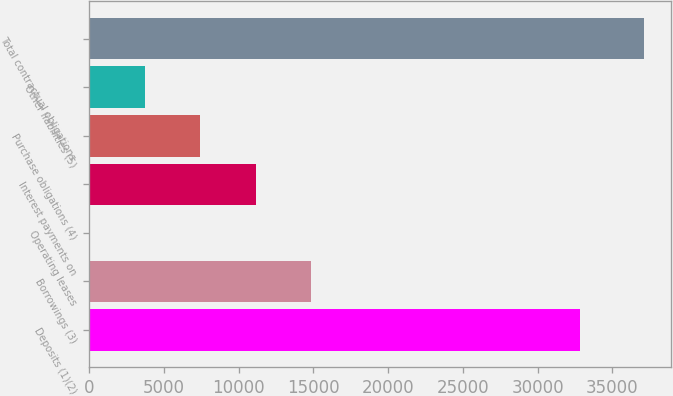Convert chart to OTSL. <chart><loc_0><loc_0><loc_500><loc_500><bar_chart><fcel>Deposits (1)(2)<fcel>Borrowings (3)<fcel>Operating leases<fcel>Interest payments on<fcel>Purchase obligations (4)<fcel>Other liabilities (5)<fcel>Total contractual obligations<nl><fcel>32831<fcel>14851.6<fcel>14<fcel>11142.2<fcel>7432.8<fcel>3723.4<fcel>37108<nl></chart> 